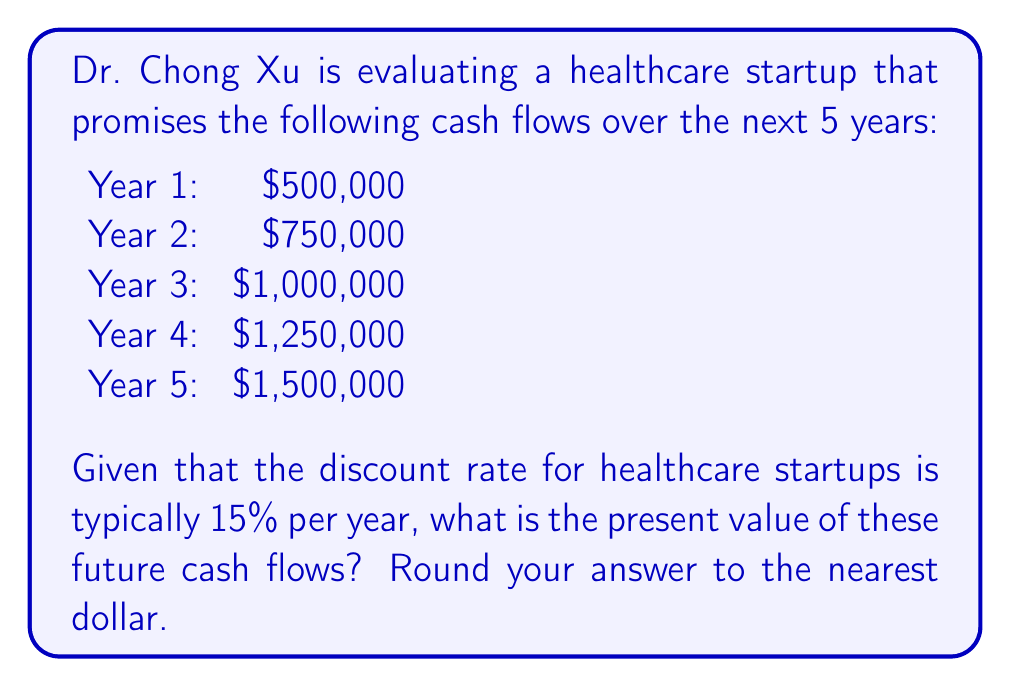Give your solution to this math problem. To compute the present value of future cash flows, we need to discount each cash flow back to the present using the given discount rate. The formula for present value is:

$$ PV = \frac{CF_t}{(1+r)^t} $$

Where:
$PV$ is the present value
$CF_t$ is the cash flow at time $t$
$r$ is the discount rate
$t$ is the time period

Let's calculate the present value for each year:

Year 1: $PV_1 = \frac{500,000}{(1+0.15)^1} = \frac{500,000}{1.15} = 434,782.61$

Year 2: $PV_2 = \frac{750,000}{(1+0.15)^2} = \frac{750,000}{1.3225} = 567,105.94$

Year 3: $PV_3 = \frac{1,000,000}{(1+0.15)^3} = \frac{1,000,000}{1.520875} = 657,533.71$

Year 4: $PV_4 = \frac{1,250,000}{(1+0.15)^4} = \frac{1,250,000}{1.74900625} = 714,690.99$

Year 5: $PV_5 = \frac{1,500,000}{(1+0.15)^5} = \frac{1,500,000}{2.011357188} = 745,645.04$

To get the total present value, we sum up all the individual present values:

$$ Total PV = PV_1 + PV_2 + PV_3 + PV_4 + PV_5 $$
$$ Total PV = 434,782.61 + 567,105.94 + 657,533.71 + 714,690.99 + 745,645.04 $$
$$ Total PV = 3,119,758.29 $$

Rounding to the nearest dollar gives us $3,119,758.
Answer: $3,119,758 